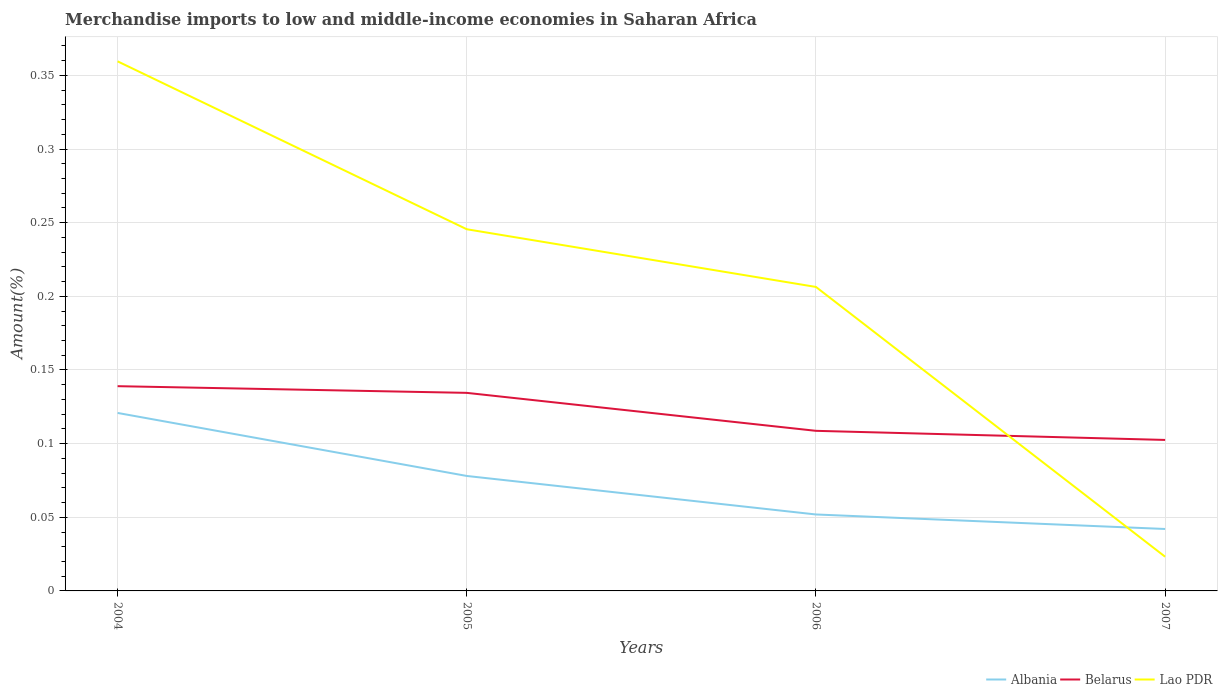Is the number of lines equal to the number of legend labels?
Ensure brevity in your answer.  Yes. Across all years, what is the maximum percentage of amount earned from merchandise imports in Lao PDR?
Your answer should be very brief. 0.02. In which year was the percentage of amount earned from merchandise imports in Lao PDR maximum?
Your answer should be very brief. 2007. What is the total percentage of amount earned from merchandise imports in Albania in the graph?
Offer a very short reply. 0.04. What is the difference between the highest and the second highest percentage of amount earned from merchandise imports in Albania?
Ensure brevity in your answer.  0.08. What is the difference between the highest and the lowest percentage of amount earned from merchandise imports in Lao PDR?
Give a very brief answer. 2. How many years are there in the graph?
Provide a succinct answer. 4. What is the difference between two consecutive major ticks on the Y-axis?
Make the answer very short. 0.05. Does the graph contain grids?
Offer a terse response. Yes. Where does the legend appear in the graph?
Your answer should be very brief. Bottom right. How many legend labels are there?
Give a very brief answer. 3. How are the legend labels stacked?
Ensure brevity in your answer.  Horizontal. What is the title of the graph?
Provide a short and direct response. Merchandise imports to low and middle-income economies in Saharan Africa. Does "Korea (Democratic)" appear as one of the legend labels in the graph?
Give a very brief answer. No. What is the label or title of the Y-axis?
Offer a terse response. Amount(%). What is the Amount(%) in Albania in 2004?
Make the answer very short. 0.12. What is the Amount(%) of Belarus in 2004?
Ensure brevity in your answer.  0.14. What is the Amount(%) of Lao PDR in 2004?
Provide a short and direct response. 0.36. What is the Amount(%) in Albania in 2005?
Give a very brief answer. 0.08. What is the Amount(%) of Belarus in 2005?
Your answer should be very brief. 0.13. What is the Amount(%) in Lao PDR in 2005?
Make the answer very short. 0.25. What is the Amount(%) of Albania in 2006?
Offer a terse response. 0.05. What is the Amount(%) in Belarus in 2006?
Provide a succinct answer. 0.11. What is the Amount(%) of Lao PDR in 2006?
Offer a terse response. 0.21. What is the Amount(%) of Albania in 2007?
Make the answer very short. 0.04. What is the Amount(%) of Belarus in 2007?
Offer a very short reply. 0.1. What is the Amount(%) in Lao PDR in 2007?
Provide a short and direct response. 0.02. Across all years, what is the maximum Amount(%) of Albania?
Offer a very short reply. 0.12. Across all years, what is the maximum Amount(%) in Belarus?
Make the answer very short. 0.14. Across all years, what is the maximum Amount(%) of Lao PDR?
Your answer should be compact. 0.36. Across all years, what is the minimum Amount(%) in Albania?
Offer a terse response. 0.04. Across all years, what is the minimum Amount(%) of Belarus?
Provide a short and direct response. 0.1. Across all years, what is the minimum Amount(%) of Lao PDR?
Provide a succinct answer. 0.02. What is the total Amount(%) in Albania in the graph?
Your answer should be compact. 0.29. What is the total Amount(%) of Belarus in the graph?
Provide a succinct answer. 0.48. What is the total Amount(%) of Lao PDR in the graph?
Keep it short and to the point. 0.83. What is the difference between the Amount(%) of Albania in 2004 and that in 2005?
Make the answer very short. 0.04. What is the difference between the Amount(%) in Belarus in 2004 and that in 2005?
Ensure brevity in your answer.  0. What is the difference between the Amount(%) in Lao PDR in 2004 and that in 2005?
Offer a terse response. 0.11. What is the difference between the Amount(%) in Albania in 2004 and that in 2006?
Provide a short and direct response. 0.07. What is the difference between the Amount(%) of Belarus in 2004 and that in 2006?
Make the answer very short. 0.03. What is the difference between the Amount(%) of Lao PDR in 2004 and that in 2006?
Your answer should be compact. 0.15. What is the difference between the Amount(%) in Albania in 2004 and that in 2007?
Your answer should be compact. 0.08. What is the difference between the Amount(%) in Belarus in 2004 and that in 2007?
Your answer should be very brief. 0.04. What is the difference between the Amount(%) of Lao PDR in 2004 and that in 2007?
Keep it short and to the point. 0.34. What is the difference between the Amount(%) of Albania in 2005 and that in 2006?
Your response must be concise. 0.03. What is the difference between the Amount(%) in Belarus in 2005 and that in 2006?
Your answer should be very brief. 0.03. What is the difference between the Amount(%) in Lao PDR in 2005 and that in 2006?
Provide a short and direct response. 0.04. What is the difference between the Amount(%) of Albania in 2005 and that in 2007?
Offer a very short reply. 0.04. What is the difference between the Amount(%) in Belarus in 2005 and that in 2007?
Your answer should be compact. 0.03. What is the difference between the Amount(%) of Lao PDR in 2005 and that in 2007?
Ensure brevity in your answer.  0.22. What is the difference between the Amount(%) in Albania in 2006 and that in 2007?
Your response must be concise. 0.01. What is the difference between the Amount(%) of Belarus in 2006 and that in 2007?
Offer a terse response. 0.01. What is the difference between the Amount(%) in Lao PDR in 2006 and that in 2007?
Keep it short and to the point. 0.18. What is the difference between the Amount(%) of Albania in 2004 and the Amount(%) of Belarus in 2005?
Your response must be concise. -0.01. What is the difference between the Amount(%) in Albania in 2004 and the Amount(%) in Lao PDR in 2005?
Your answer should be compact. -0.12. What is the difference between the Amount(%) of Belarus in 2004 and the Amount(%) of Lao PDR in 2005?
Your answer should be very brief. -0.11. What is the difference between the Amount(%) of Albania in 2004 and the Amount(%) of Belarus in 2006?
Provide a succinct answer. 0.01. What is the difference between the Amount(%) of Albania in 2004 and the Amount(%) of Lao PDR in 2006?
Make the answer very short. -0.09. What is the difference between the Amount(%) in Belarus in 2004 and the Amount(%) in Lao PDR in 2006?
Ensure brevity in your answer.  -0.07. What is the difference between the Amount(%) in Albania in 2004 and the Amount(%) in Belarus in 2007?
Offer a terse response. 0.02. What is the difference between the Amount(%) in Albania in 2004 and the Amount(%) in Lao PDR in 2007?
Your answer should be compact. 0.1. What is the difference between the Amount(%) in Belarus in 2004 and the Amount(%) in Lao PDR in 2007?
Ensure brevity in your answer.  0.12. What is the difference between the Amount(%) of Albania in 2005 and the Amount(%) of Belarus in 2006?
Give a very brief answer. -0.03. What is the difference between the Amount(%) in Albania in 2005 and the Amount(%) in Lao PDR in 2006?
Keep it short and to the point. -0.13. What is the difference between the Amount(%) of Belarus in 2005 and the Amount(%) of Lao PDR in 2006?
Your response must be concise. -0.07. What is the difference between the Amount(%) of Albania in 2005 and the Amount(%) of Belarus in 2007?
Provide a succinct answer. -0.02. What is the difference between the Amount(%) of Albania in 2005 and the Amount(%) of Lao PDR in 2007?
Your answer should be very brief. 0.05. What is the difference between the Amount(%) of Belarus in 2005 and the Amount(%) of Lao PDR in 2007?
Make the answer very short. 0.11. What is the difference between the Amount(%) of Albania in 2006 and the Amount(%) of Belarus in 2007?
Give a very brief answer. -0.05. What is the difference between the Amount(%) in Albania in 2006 and the Amount(%) in Lao PDR in 2007?
Provide a short and direct response. 0.03. What is the difference between the Amount(%) of Belarus in 2006 and the Amount(%) of Lao PDR in 2007?
Your answer should be very brief. 0.09. What is the average Amount(%) in Albania per year?
Provide a short and direct response. 0.07. What is the average Amount(%) of Belarus per year?
Ensure brevity in your answer.  0.12. What is the average Amount(%) of Lao PDR per year?
Keep it short and to the point. 0.21. In the year 2004, what is the difference between the Amount(%) in Albania and Amount(%) in Belarus?
Keep it short and to the point. -0.02. In the year 2004, what is the difference between the Amount(%) of Albania and Amount(%) of Lao PDR?
Offer a very short reply. -0.24. In the year 2004, what is the difference between the Amount(%) in Belarus and Amount(%) in Lao PDR?
Ensure brevity in your answer.  -0.22. In the year 2005, what is the difference between the Amount(%) of Albania and Amount(%) of Belarus?
Offer a terse response. -0.06. In the year 2005, what is the difference between the Amount(%) of Albania and Amount(%) of Lao PDR?
Ensure brevity in your answer.  -0.17. In the year 2005, what is the difference between the Amount(%) of Belarus and Amount(%) of Lao PDR?
Offer a terse response. -0.11. In the year 2006, what is the difference between the Amount(%) of Albania and Amount(%) of Belarus?
Make the answer very short. -0.06. In the year 2006, what is the difference between the Amount(%) of Albania and Amount(%) of Lao PDR?
Keep it short and to the point. -0.15. In the year 2006, what is the difference between the Amount(%) of Belarus and Amount(%) of Lao PDR?
Offer a terse response. -0.1. In the year 2007, what is the difference between the Amount(%) in Albania and Amount(%) in Belarus?
Provide a succinct answer. -0.06. In the year 2007, what is the difference between the Amount(%) of Albania and Amount(%) of Lao PDR?
Make the answer very short. 0.02. In the year 2007, what is the difference between the Amount(%) in Belarus and Amount(%) in Lao PDR?
Keep it short and to the point. 0.08. What is the ratio of the Amount(%) in Albania in 2004 to that in 2005?
Give a very brief answer. 1.55. What is the ratio of the Amount(%) of Belarus in 2004 to that in 2005?
Provide a succinct answer. 1.03. What is the ratio of the Amount(%) in Lao PDR in 2004 to that in 2005?
Keep it short and to the point. 1.46. What is the ratio of the Amount(%) in Albania in 2004 to that in 2006?
Your answer should be very brief. 2.33. What is the ratio of the Amount(%) of Belarus in 2004 to that in 2006?
Your answer should be compact. 1.28. What is the ratio of the Amount(%) in Lao PDR in 2004 to that in 2006?
Your answer should be very brief. 1.74. What is the ratio of the Amount(%) of Albania in 2004 to that in 2007?
Keep it short and to the point. 2.87. What is the ratio of the Amount(%) of Belarus in 2004 to that in 2007?
Give a very brief answer. 1.36. What is the ratio of the Amount(%) in Lao PDR in 2004 to that in 2007?
Your answer should be compact. 15.49. What is the ratio of the Amount(%) of Albania in 2005 to that in 2006?
Offer a terse response. 1.5. What is the ratio of the Amount(%) in Belarus in 2005 to that in 2006?
Offer a terse response. 1.24. What is the ratio of the Amount(%) in Lao PDR in 2005 to that in 2006?
Your answer should be compact. 1.19. What is the ratio of the Amount(%) in Albania in 2005 to that in 2007?
Offer a terse response. 1.86. What is the ratio of the Amount(%) of Belarus in 2005 to that in 2007?
Your answer should be compact. 1.31. What is the ratio of the Amount(%) in Lao PDR in 2005 to that in 2007?
Your answer should be very brief. 10.58. What is the ratio of the Amount(%) of Albania in 2006 to that in 2007?
Provide a short and direct response. 1.23. What is the ratio of the Amount(%) in Belarus in 2006 to that in 2007?
Provide a succinct answer. 1.06. What is the ratio of the Amount(%) in Lao PDR in 2006 to that in 2007?
Offer a terse response. 8.89. What is the difference between the highest and the second highest Amount(%) in Albania?
Make the answer very short. 0.04. What is the difference between the highest and the second highest Amount(%) of Belarus?
Offer a very short reply. 0. What is the difference between the highest and the second highest Amount(%) of Lao PDR?
Keep it short and to the point. 0.11. What is the difference between the highest and the lowest Amount(%) in Albania?
Keep it short and to the point. 0.08. What is the difference between the highest and the lowest Amount(%) in Belarus?
Offer a very short reply. 0.04. What is the difference between the highest and the lowest Amount(%) of Lao PDR?
Provide a succinct answer. 0.34. 